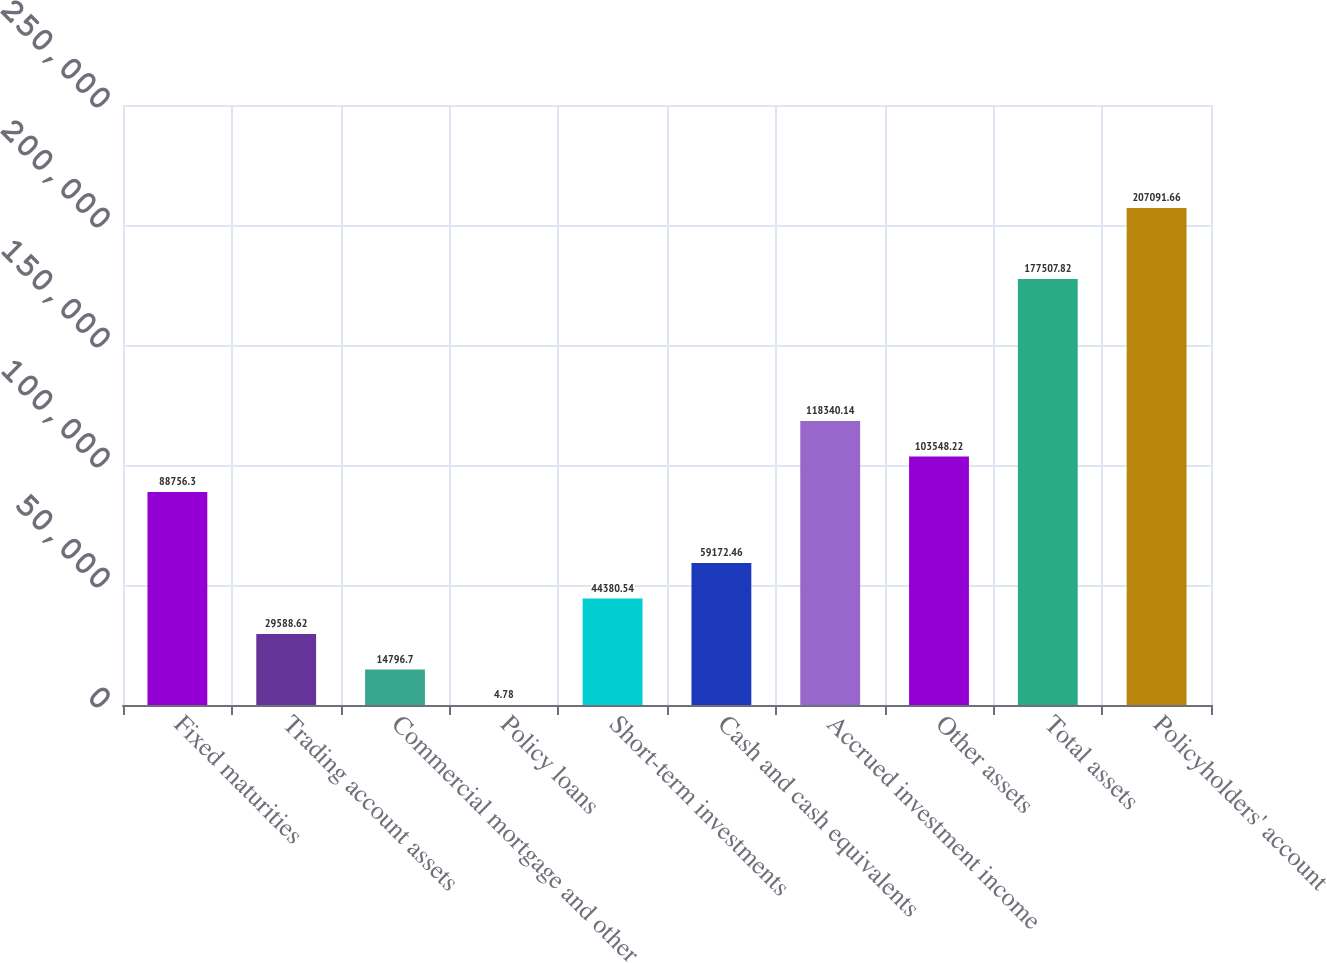Convert chart. <chart><loc_0><loc_0><loc_500><loc_500><bar_chart><fcel>Fixed maturities<fcel>Trading account assets<fcel>Commercial mortgage and other<fcel>Policy loans<fcel>Short-term investments<fcel>Cash and cash equivalents<fcel>Accrued investment income<fcel>Other assets<fcel>Total assets<fcel>Policyholders' account<nl><fcel>88756.3<fcel>29588.6<fcel>14796.7<fcel>4.78<fcel>44380.5<fcel>59172.5<fcel>118340<fcel>103548<fcel>177508<fcel>207092<nl></chart> 